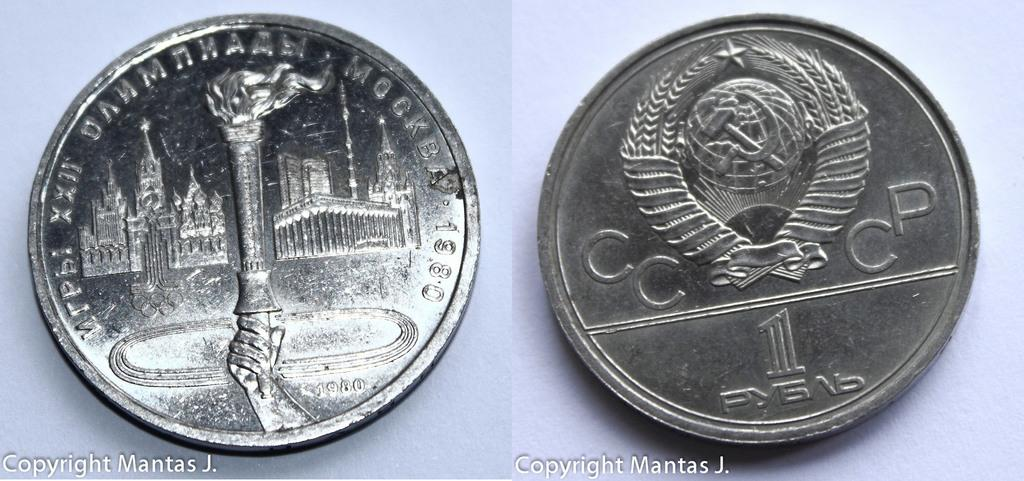Provide a one-sentence caption for the provided image. A coin is featured in a photo that is copyrighted by Mantas J. 